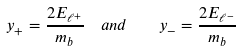Convert formula to latex. <formula><loc_0><loc_0><loc_500><loc_500>y _ { + } = \frac { 2 E _ { \ell ^ { + } } } { m _ { b } } \ \ a n d \quad y _ { - } = \frac { 2 E _ { \ell ^ { - } } } { m _ { b } }</formula> 